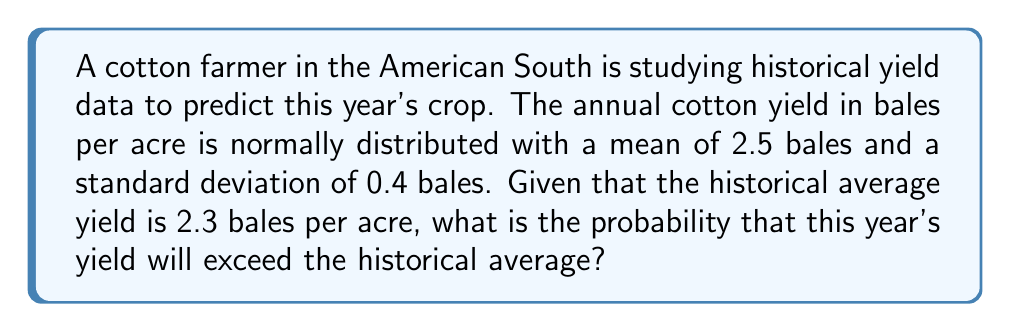What is the answer to this math problem? Let's approach this step-by-step:

1) Let X be the random variable representing the cotton yield in bales per acre.
   X ~ N(μ = 2.5, σ = 0.4)

2) We want to find P(X > 2.3), where 2.3 is the historical average.

3) To solve this, we need to standardize the normal distribution:
   Z = (X - μ) / σ
   
4) We can rewrite our probability as:
   P(X > 2.3) = P(Z > (2.3 - 2.5) / 0.4)

5) Calculate the Z-score:
   Z = (2.3 - 2.5) / 0.4 = -0.5

6) Now we need to find P(Z > -0.5)

7) Using the standard normal distribution table or a calculator:
   P(Z > -0.5) = 1 - P(Z < -0.5) = 1 - 0.3085 = 0.6915

Therefore, the probability that this year's yield will exceed the historical average is approximately 0.6915 or 69.15%.
Answer: 0.6915 